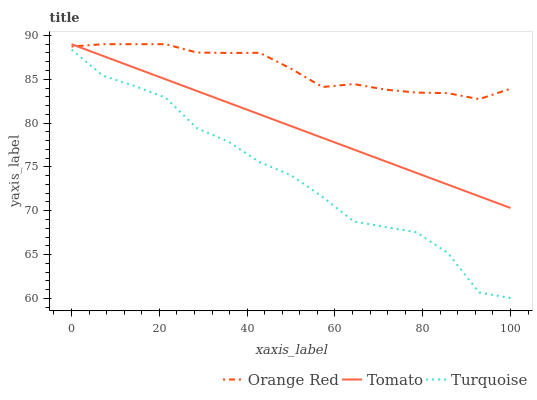Does Orange Red have the minimum area under the curve?
Answer yes or no. No. Does Turquoise have the maximum area under the curve?
Answer yes or no. No. Is Orange Red the smoothest?
Answer yes or no. No. Is Orange Red the roughest?
Answer yes or no. No. Does Orange Red have the lowest value?
Answer yes or no. No. Does Turquoise have the highest value?
Answer yes or no. No. Is Turquoise less than Orange Red?
Answer yes or no. Yes. Is Tomato greater than Turquoise?
Answer yes or no. Yes. Does Turquoise intersect Orange Red?
Answer yes or no. No. 